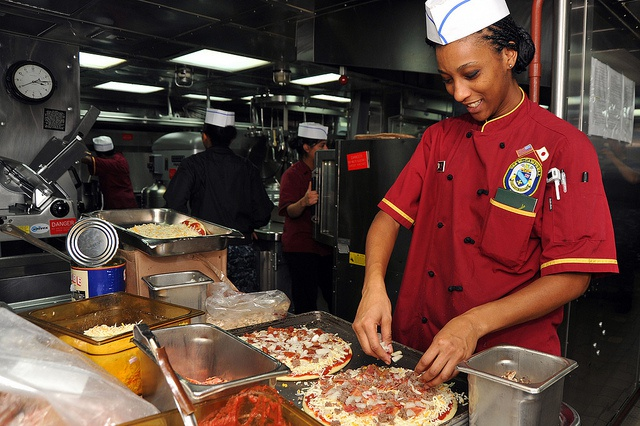Describe the objects in this image and their specific colors. I can see people in black, brown, and maroon tones, people in black, darkgray, gray, and lightgray tones, bowl in black and gray tones, pizza in black, tan, and salmon tones, and people in black, maroon, darkgray, and brown tones in this image. 